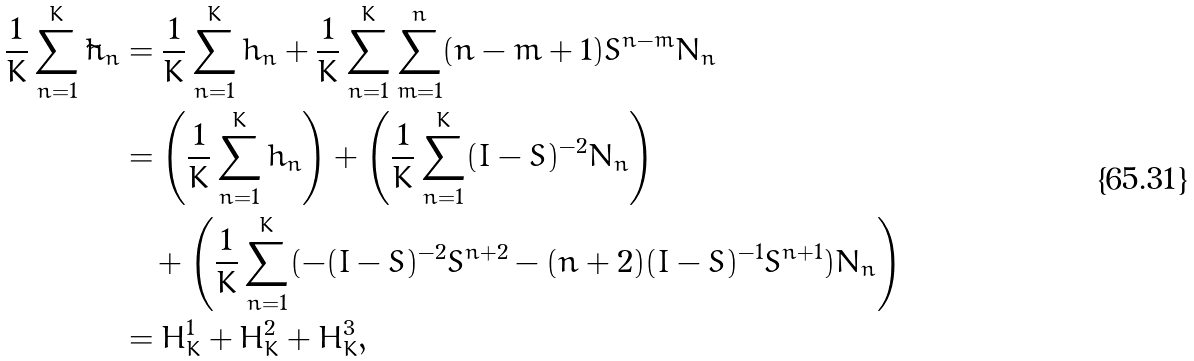Convert formula to latex. <formula><loc_0><loc_0><loc_500><loc_500>\frac { 1 } { K } \sum _ { n = 1 } ^ { K } \tilde { h } _ { n } & = \frac { 1 } { K } \sum _ { n = 1 } ^ { K } h _ { n } + \frac { 1 } { K } \sum _ { n = 1 } ^ { K } \sum _ { m = 1 } ^ { n } ( n - m + 1 ) S ^ { n - m } N _ { n } \\ & = \left ( \frac { 1 } { K } \sum _ { n = 1 } ^ { K } h _ { n } \right ) + \left ( \frac { 1 } { K } \sum _ { n = 1 } ^ { K } ( I - S ) ^ { - 2 } N _ { n } \right ) \\ & \quad + \left ( \frac { 1 } { K } \sum _ { n = 1 } ^ { K } ( - ( I - S ) ^ { - 2 } S ^ { n + 2 } - ( n + 2 ) ( I - S ) ^ { - 1 } S ^ { n + 1 } ) N _ { n } \right ) \\ & = H ^ { 1 } _ { K } + H ^ { 2 } _ { K } + H ^ { 3 } _ { K } ,</formula> 